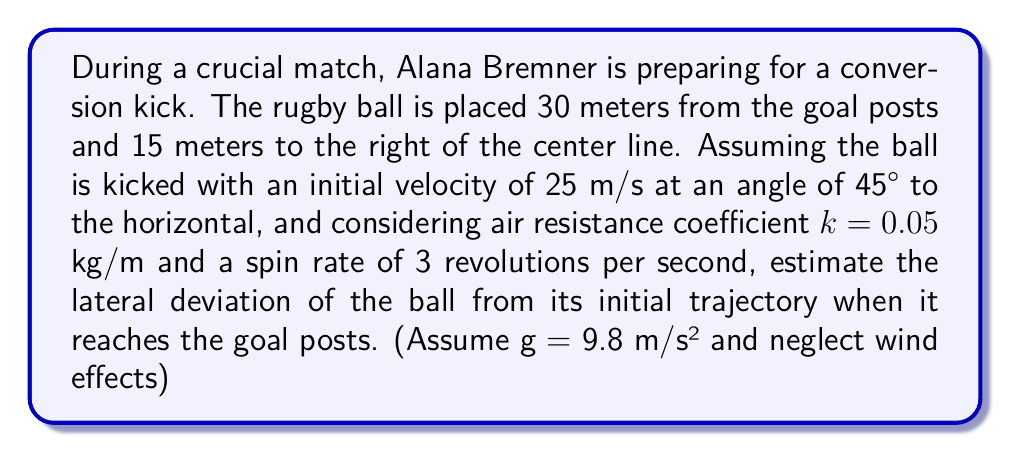Solve this math problem. To solve this problem, we need to consider the effects of air resistance and spin on the trajectory of the rugby ball. Let's break it down step-by-step:

1) First, let's calculate the time it takes for the ball to reach the goal posts:

   Distance to goal posts: $d = \sqrt{30^2 + 15^2} = 33.54$ m

   Initial velocity in x-direction: $v_{0x} = 25 \cos(45°) = 17.68$ m/s

   Time: $t = \frac{d}{v_{0x}} = \frac{33.54}{17.68} = 1.90$ s

2) Now, let's consider the effect of air resistance. The drag force is given by:

   $F_d = -kv$

   Where $k$ is the air resistance coefficient and $v$ is the velocity.

3) The effect of air resistance on the horizontal velocity can be approximated as:

   $v_x = v_{0x}e^{-\frac{k}{m}t}$

   Where $m$ is the mass of the ball (assume $m = 0.45$ kg for a standard rugby ball)

4) The lateral force due to spin (Magnus effect) is given by:

   $F_L = \frac{1}{2}\rho A v^2 C_L$

   Where $\rho$ is air density (assume $1.225$ kg/m³), $A$ is cross-sectional area of the ball (assume $0.04$ m²), $v$ is velocity, and $C_L$ is the lift coefficient (proportional to spin rate, assume $0.1$ for this spin rate)

5) The lateral acceleration due to this force is:

   $a_L = \frac{F_L}{m} = \frac{1}{2}\frac{\rho A v^2 C_L}{m}$

6) The lateral deviation can be estimated using:

   $y = \frac{1}{2}a_L t^2$

7) Plugging in the values:

   $v = 25 e^{-\frac{0.05}{0.45}1.90} = 20.41$ m/s

   $a_L = \frac{1}{2}\frac{1.225 \cdot 0.04 \cdot 20.41^2 \cdot 0.1}{0.45} = 2.27$ m/s²

   $y = \frac{1}{2} \cdot 2.27 \cdot 1.90^2 = 4.09$ m

Therefore, the estimated lateral deviation is approximately 4.09 meters.
Answer: The estimated lateral deviation of the rugby ball from its initial trajectory when it reaches the goal posts is approximately 4.09 meters. 